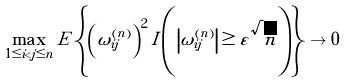Convert formula to latex. <formula><loc_0><loc_0><loc_500><loc_500>\max _ { 1 \leq i < j \leq n } E \left \{ \left ( \omega _ { i j } ^ { ( n ) } \right ) ^ { 2 } I \left ( \left | \omega _ { i j } ^ { ( n ) } \right | \geq \varepsilon \sqrt { n } \right ) \right \} \to 0</formula> 